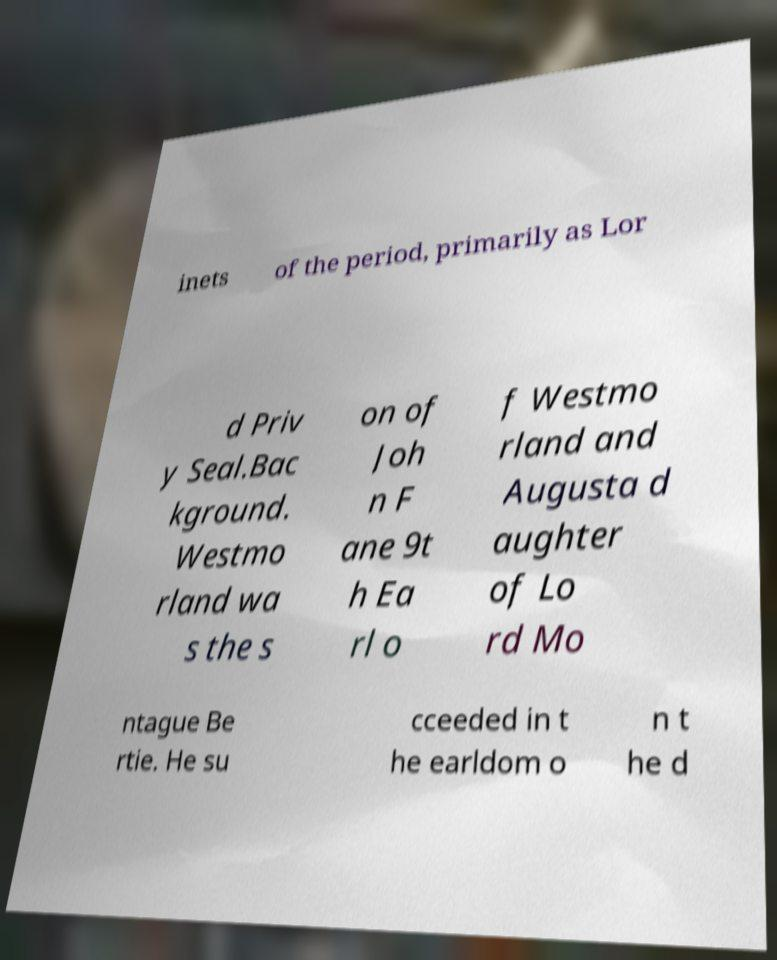Please identify and transcribe the text found in this image. inets of the period, primarily as Lor d Priv y Seal.Bac kground. Westmo rland wa s the s on of Joh n F ane 9t h Ea rl o f Westmo rland and Augusta d aughter of Lo rd Mo ntague Be rtie. He su cceeded in t he earldom o n t he d 